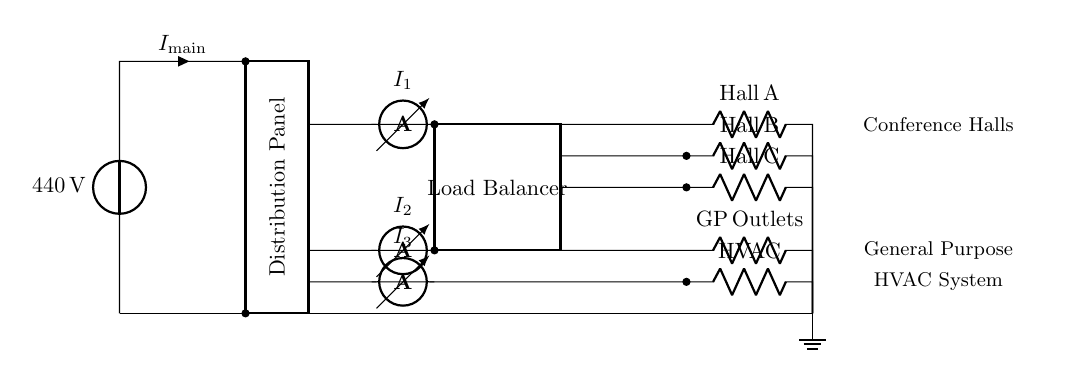What is the main voltage level in this circuit? The main voltage is indicated near the power source and is given as 440 volts.
Answer: 440 volts What loads are connected to the distribution panel? The diagram shows three conference hall circuits, general purpose outlets, and an HVAC system connected to the distribution panel.
Answer: Hall A, Hall B, Hall C, General Purpose Outlets, HVAC How many ammeters are present in the circuit? Three ammeters are displayed, each measuring current for different loads: I1 for Hall A, I2 for General Purpose Outlets, and I3 for the HVAC system.
Answer: Three What is the purpose of the load balancer? The load balancer's role is to distribute the electrical load across the different circuits, helping to prevent overloading any single circuit during high power usage.
Answer: To distribute electrical load What is the total number of circuits served by the distribution panel? The diagram shows a total of five circuits: three for conference halls, one for general purpose outlets, and one for the HVAC system, making a total of five distinct loads.
Answer: Five What current is measured for the HVAC system? The current specifically measuring the HVAC system is labeled as I3, which corresponds to its branch in the circuit.
Answer: I3 